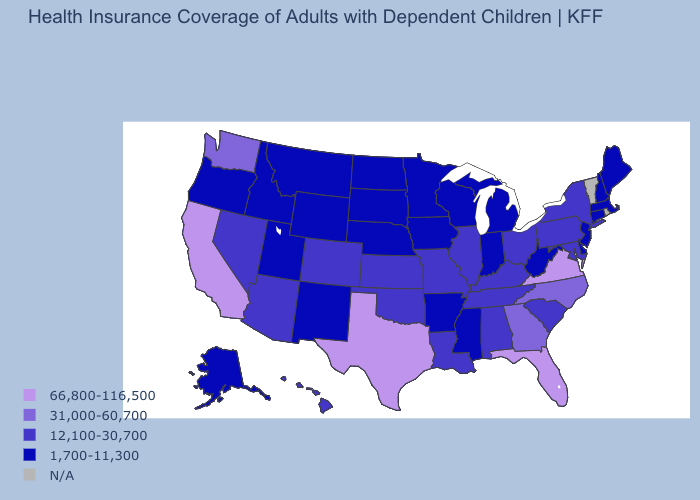Among the states that border Maryland , which have the highest value?
Concise answer only. Virginia. What is the value of New Mexico?
Concise answer only. 1,700-11,300. What is the value of North Dakota?
Short answer required. 1,700-11,300. Among the states that border Florida , does Alabama have the lowest value?
Be succinct. Yes. What is the value of North Dakota?
Concise answer only. 1,700-11,300. Among the states that border North Carolina , which have the highest value?
Keep it brief. Virginia. Which states have the lowest value in the South?
Answer briefly. Arkansas, Delaware, Mississippi, West Virginia. Does Illinois have the lowest value in the USA?
Write a very short answer. No. Does the first symbol in the legend represent the smallest category?
Short answer required. No. What is the value of Arkansas?
Keep it brief. 1,700-11,300. What is the highest value in the USA?
Quick response, please. 66,800-116,500. Name the states that have a value in the range 12,100-30,700?
Quick response, please. Alabama, Arizona, Colorado, Hawaii, Illinois, Kansas, Kentucky, Louisiana, Maryland, Missouri, Nevada, New York, Ohio, Oklahoma, Pennsylvania, South Carolina, Tennessee. What is the highest value in the USA?
Keep it brief. 66,800-116,500. 